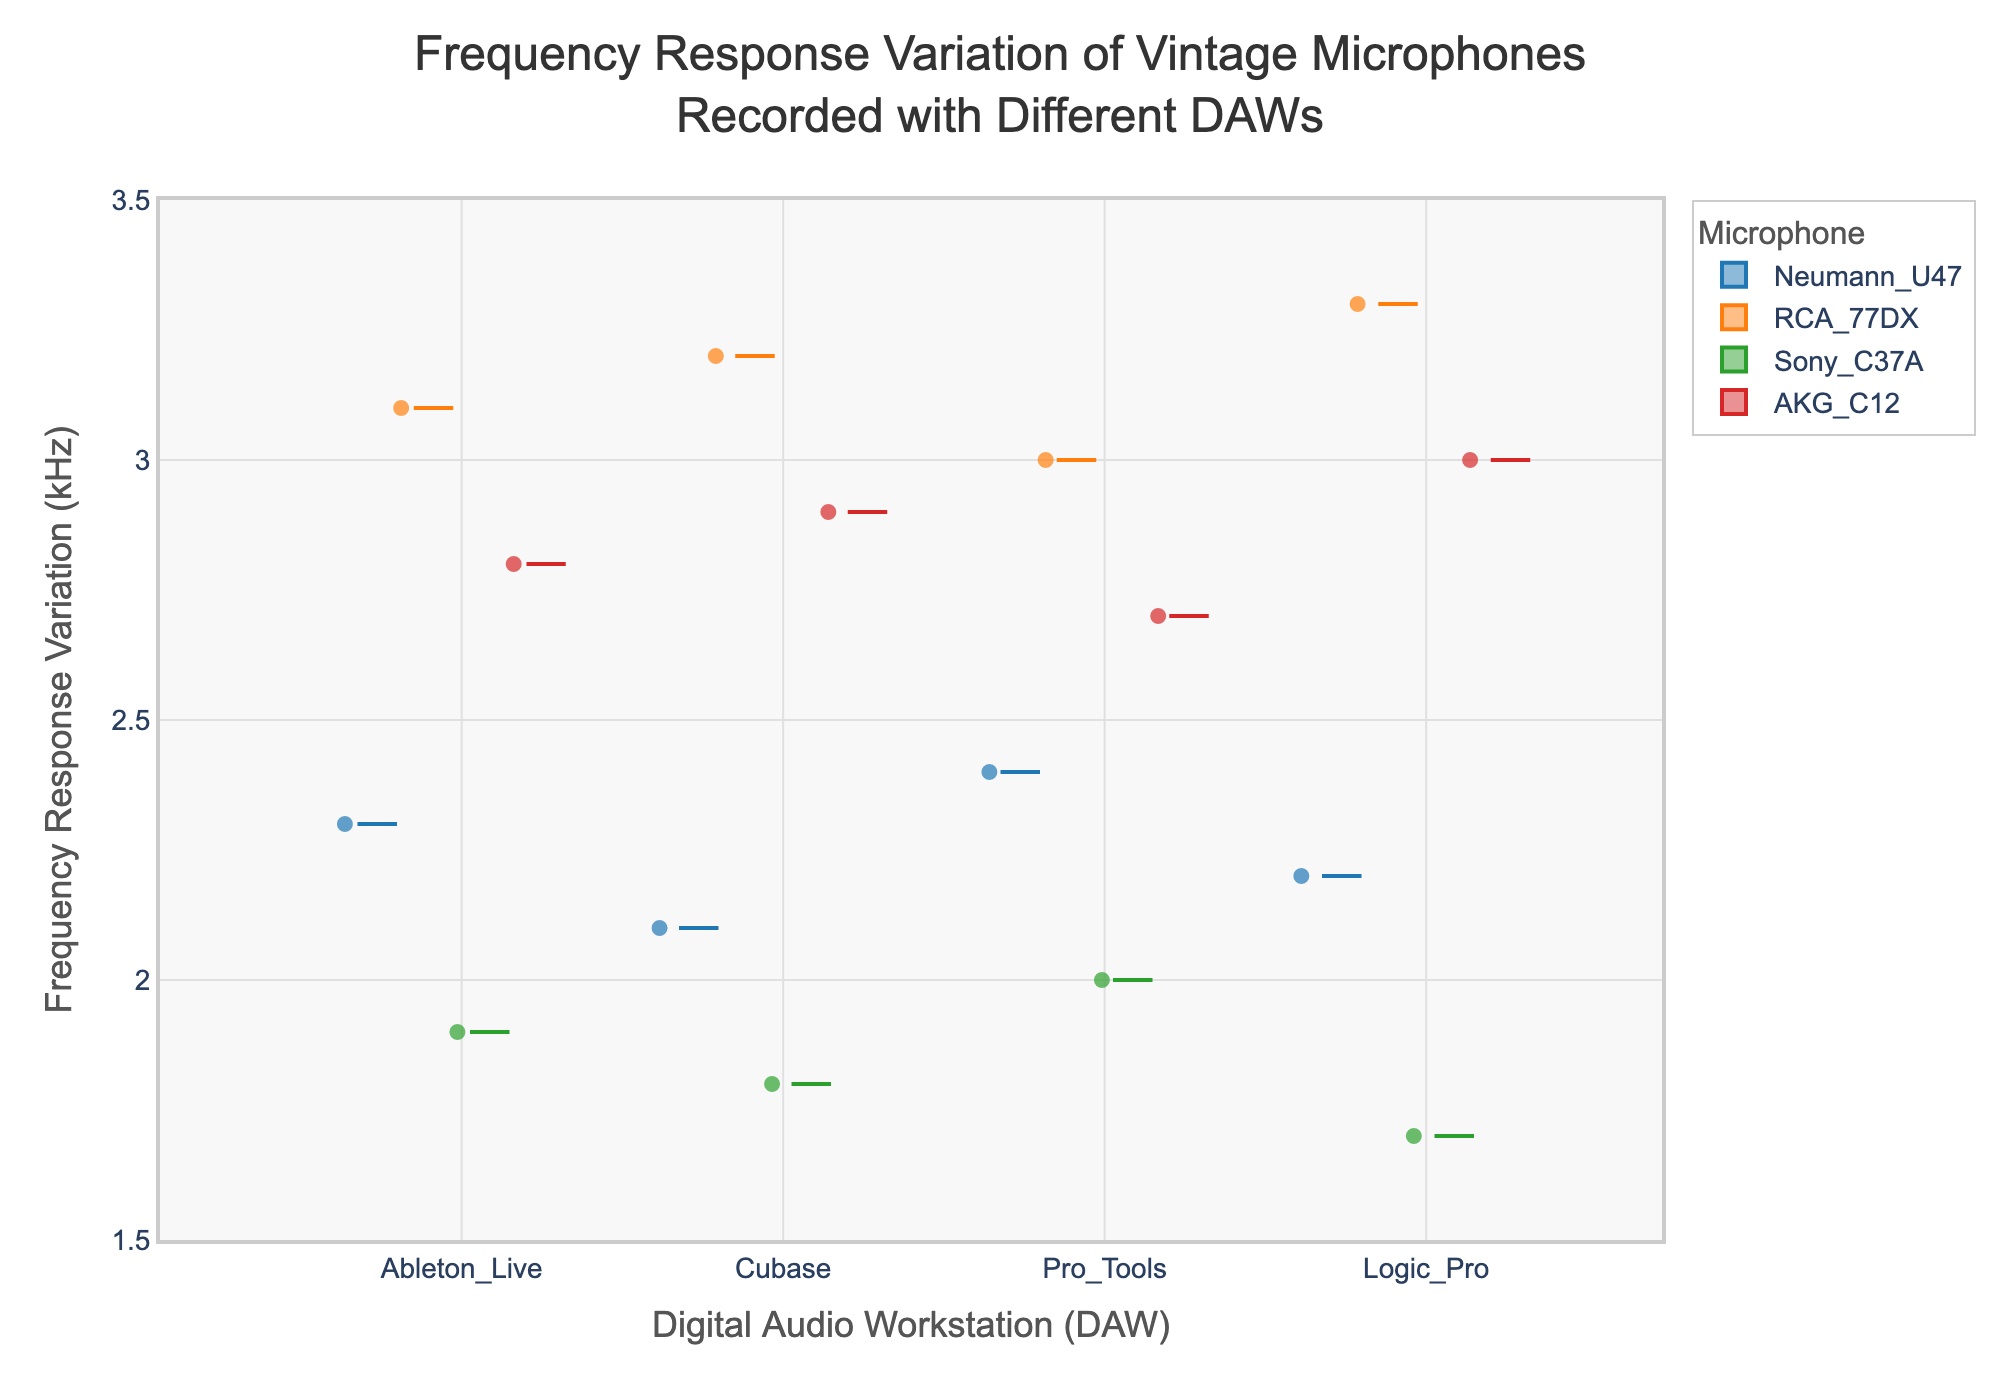What's the title of the figure? The title of the figure is displayed prominently at the top of the chart. It reads "Frequency Response Variation of Vintage Microphones Recorded with Different DAWs".
Answer: Frequency Response Variation of Vintage Microphones Recorded with Different DAWs Which DAW shows the highest frequency response variation for the RCA 77DX microphone? In the box plot for the RCA 77DX microphone, the highest frequency response variation can be seen for Logic Pro. The end of the whisker for Logic Pro extends the highest among the DAWs for RCA 77DX.
Answer: Logic Pro What is the range of frequency response variation for the Neumann U47 microphone across all DAWs? The range can be determined by identifying the minimum and maximum values of the frequency response variation for the Neumann U47 microphone. The lowest value is 2.1 kHz (Cubase) and the highest value is 2.4 kHz (Pro Tools). Thus, the range is 2.4 - 2.1 kHz.
Answer: 0.3 kHz Which microphone has the smallest frequency response variation in Ableton Live? By looking at the box plots for each microphone in the Ableton Live category, the smallest frequency response variation is for the Sony C37A, where the median line is the lowest among all the microphones.
Answer: Sony C37A Which DAW has the most consistent frequency response variation for the AKG C12 microphone, indicated by the shortest interquartile range (IQR)? The shortest interquartile range, represented by the length of the box, can be observed for Pro Tools for the AKG C12 microphone.
Answer: Pro Tools For the Sony C37A microphone, which DAW exhibits the median frequency response variation? The median is marked by the line inside the box. For the Sony C37A microphone, the median frequency response variation is observed in Pro Tools.
Answer: Pro Tools Compare the median frequency response variations for the Neumann U47 and the RCA 77DX microphones in Pro Tools. Which one is higher? The median lines inside the box plots for Pro Tools show that the median frequency response variation for the RCA 77DX is higher (3.0 kHz) compared to the Neumann U47 (2.4 kHz).
Answer: RCA 77DX Is there any overlap in the notches between the box plots for the RCA 77DX and AKG C12 microphones in Logic Pro? Notched box plots show an overlap if their notches intersect. For RCA 77DX and AKG C12 in Logic Pro, we observe that their notches do not overlap, indicating no overlap in their confidence intervals for the median.
Answer: No What's the interquartile range (IQR) of frequency response variation for the Neumann U47 microphone in Cubase? IQR is the difference between the third quartile (Q3) and the first quartile (Q1). For Neumann U47 in Cubase, Q3 is 2.2 kHz and Q1 is 2.0 kHz. Thus, IQR = Q3 - Q1 = 2.2 kHz - 2.0 kHz.
Answer: 0.2 kHz Which DAW generally shows the highest variability in frequency response for all microphones? The overall variability in each DAW can be compared by looking at the lengths of the boxes and whiskers for all microphones. Logic Pro tends to show the highest variability, with many microphones having long whiskers and wide boxes.
Answer: Logic Pro 